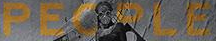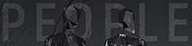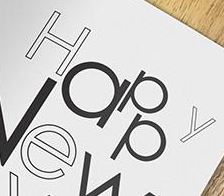What words are shown in these images in order, separated by a semicolon? PEOPLE; PEOPLE; Happy 